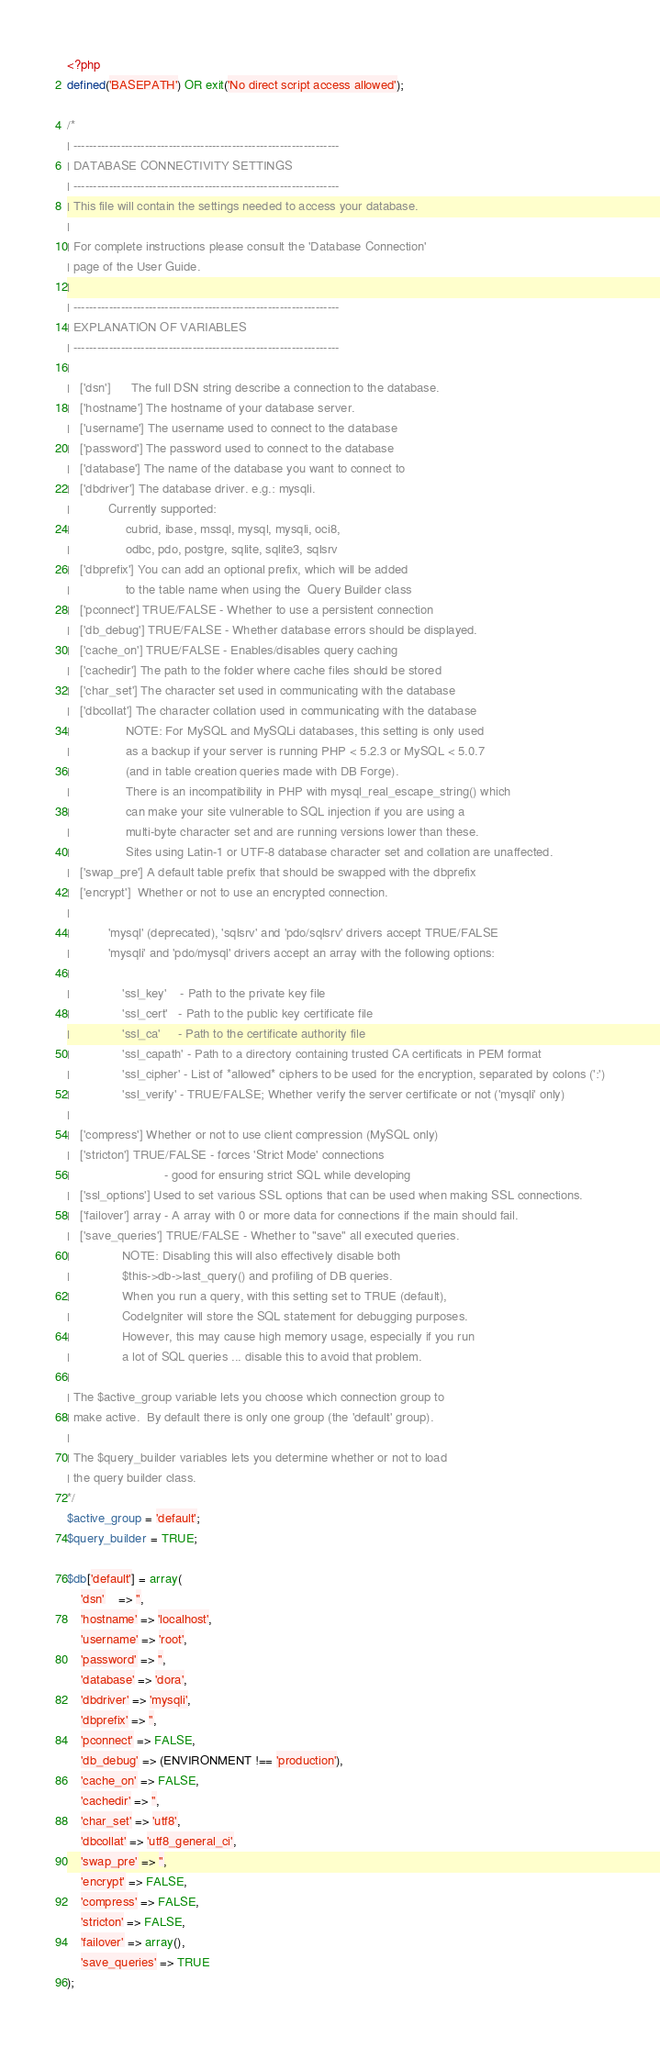<code> <loc_0><loc_0><loc_500><loc_500><_PHP_><?php
defined('BASEPATH') OR exit('No direct script access allowed');

/*
| -------------------------------------------------------------------
| DATABASE CONNECTIVITY SETTINGS
| -------------------------------------------------------------------
| This file will contain the settings needed to access your database.
|
| For complete instructions please consult the 'Database Connection'
| page of the User Guide.
|
| -------------------------------------------------------------------
| EXPLANATION OF VARIABLES
| -------------------------------------------------------------------
|
|	['dsn']      The full DSN string describe a connection to the database.
|	['hostname'] The hostname of your database server.
|	['username'] The username used to connect to the database
|	['password'] The password used to connect to the database
|	['database'] The name of the database you want to connect to
|	['dbdriver'] The database driver. e.g.: mysqli.
|			Currently supported:
|				 cubrid, ibase, mssql, mysql, mysqli, oci8,
|				 odbc, pdo, postgre, sqlite, sqlite3, sqlsrv
|	['dbprefix'] You can add an optional prefix, which will be added
|				 to the table name when using the  Query Builder class
|	['pconnect'] TRUE/FALSE - Whether to use a persistent connection
|	['db_debug'] TRUE/FALSE - Whether database errors should be displayed.
|	['cache_on'] TRUE/FALSE - Enables/disables query caching
|	['cachedir'] The path to the folder where cache files should be stored
|	['char_set'] The character set used in communicating with the database
|	['dbcollat'] The character collation used in communicating with the database
|				 NOTE: For MySQL and MySQLi databases, this setting is only used
| 				 as a backup if your server is running PHP < 5.2.3 or MySQL < 5.0.7
|				 (and in table creation queries made with DB Forge).
| 				 There is an incompatibility in PHP with mysql_real_escape_string() which
| 				 can make your site vulnerable to SQL injection if you are using a
| 				 multi-byte character set and are running versions lower than these.
| 				 Sites using Latin-1 or UTF-8 database character set and collation are unaffected.
|	['swap_pre'] A default table prefix that should be swapped with the dbprefix
|	['encrypt']  Whether or not to use an encrypted connection.
|
|			'mysql' (deprecated), 'sqlsrv' and 'pdo/sqlsrv' drivers accept TRUE/FALSE
|			'mysqli' and 'pdo/mysql' drivers accept an array with the following options:
|
|				'ssl_key'    - Path to the private key file
|				'ssl_cert'   - Path to the public key certificate file
|				'ssl_ca'     - Path to the certificate authority file
|				'ssl_capath' - Path to a directory containing trusted CA certificats in PEM format
|				'ssl_cipher' - List of *allowed* ciphers to be used for the encryption, separated by colons (':')
|				'ssl_verify' - TRUE/FALSE; Whether verify the server certificate or not ('mysqli' only)
|
|	['compress'] Whether or not to use client compression (MySQL only)
|	['stricton'] TRUE/FALSE - forces 'Strict Mode' connections
|							- good for ensuring strict SQL while developing
|	['ssl_options']	Used to set various SSL options that can be used when making SSL connections.
|	['failover'] array - A array with 0 or more data for connections if the main should fail.
|	['save_queries'] TRUE/FALSE - Whether to "save" all executed queries.
| 				NOTE: Disabling this will also effectively disable both
| 				$this->db->last_query() and profiling of DB queries.
| 				When you run a query, with this setting set to TRUE (default),
| 				CodeIgniter will store the SQL statement for debugging purposes.
| 				However, this may cause high memory usage, especially if you run
| 				a lot of SQL queries ... disable this to avoid that problem.
|
| The $active_group variable lets you choose which connection group to
| make active.  By default there is only one group (the 'default' group).
|
| The $query_builder variables lets you determine whether or not to load
| the query builder class.
*/
$active_group = 'default';
$query_builder = TRUE;

$db['default'] = array(
	'dsn'	=> '',
	'hostname' => 'localhost',
	'username' => 'root',
	'password' => '',
	'database' => 'dora',
	'dbdriver' => 'mysqli',
	'dbprefix' => '',
	'pconnect' => FALSE,
	'db_debug' => (ENVIRONMENT !== 'production'),
	'cache_on' => FALSE,
	'cachedir' => '',
	'char_set' => 'utf8',
	'dbcollat' => 'utf8_general_ci',
	'swap_pre' => '',
	'encrypt' => FALSE,
	'compress' => FALSE,
	'stricton' => FALSE,
	'failover' => array(),
	'save_queries' => TRUE
);
</code> 